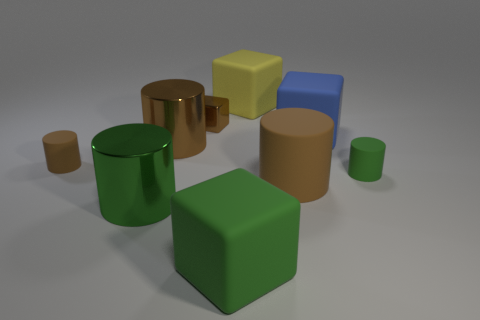There is a matte cylinder that is to the right of the large brown rubber object; what is its color?
Provide a succinct answer. Green. There is a large matte object that is the same shape as the small brown rubber thing; what is its color?
Your answer should be compact. Brown. Are there more green matte cubes than large brown metallic spheres?
Offer a very short reply. Yes. Are the big green block and the tiny brown cylinder made of the same material?
Offer a very short reply. Yes. What number of large yellow things are made of the same material as the large blue cube?
Provide a succinct answer. 1. Do the blue thing and the cube in front of the tiny green thing have the same size?
Offer a very short reply. Yes. The big object that is both on the left side of the large blue rubber block and right of the big yellow block is what color?
Your answer should be compact. Brown. Are there any matte cylinders that are to the right of the tiny cylinder on the left side of the blue matte cube?
Provide a succinct answer. Yes. Are there the same number of big cylinders that are left of the tiny brown shiny cube and large brown metal cylinders?
Ensure brevity in your answer.  No. How many brown metal cylinders are behind the cube in front of the brown rubber object behind the green rubber cylinder?
Give a very brief answer. 1. 